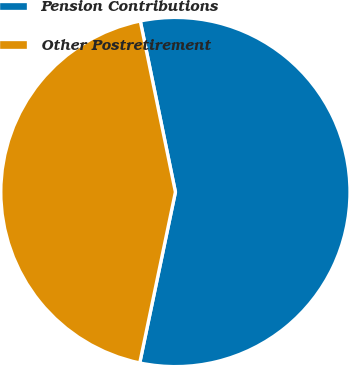Convert chart to OTSL. <chart><loc_0><loc_0><loc_500><loc_500><pie_chart><fcel>Pension Contributions<fcel>Other Postretirement<nl><fcel>56.5%<fcel>43.5%<nl></chart> 